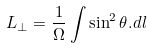<formula> <loc_0><loc_0><loc_500><loc_500>L _ { \bot } = \frac { 1 } { \Omega } \int { \sin ^ { 2 } \theta . d l }</formula> 